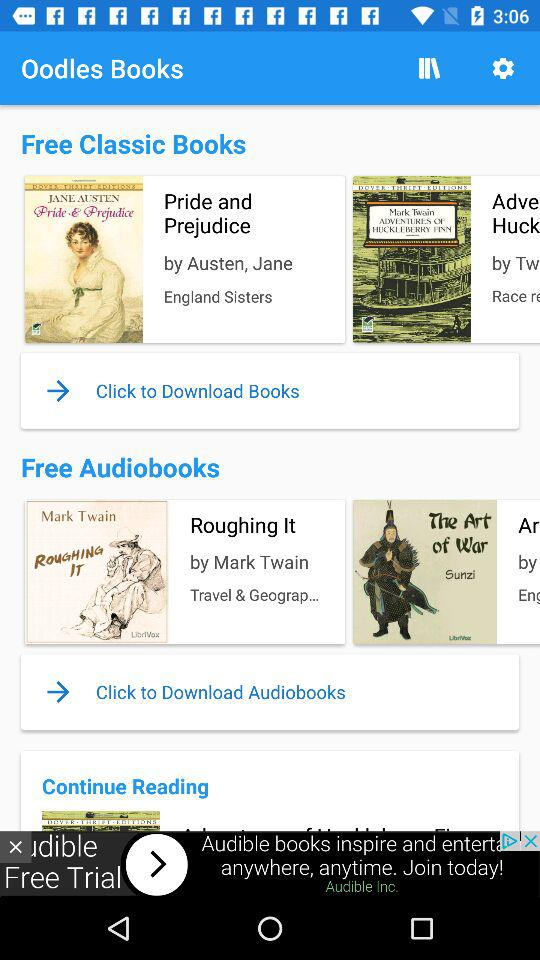How many books are free?
Answer the question using a single word or phrase. 2 